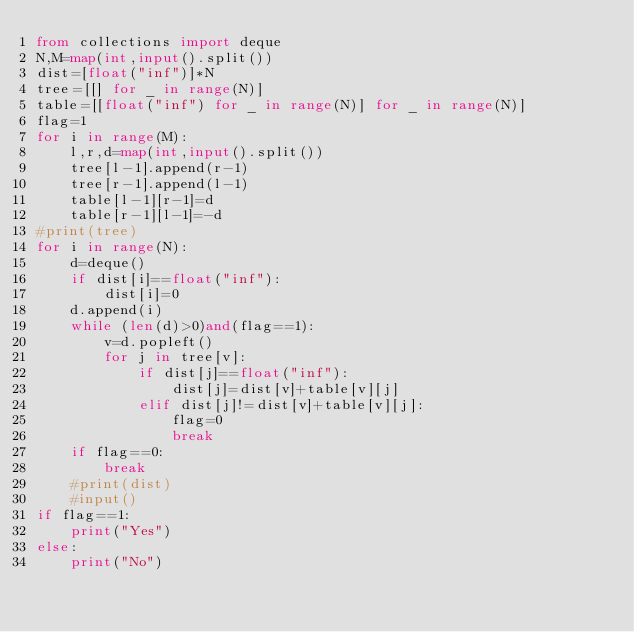Convert code to text. <code><loc_0><loc_0><loc_500><loc_500><_Python_>from collections import deque
N,M=map(int,input().split())
dist=[float("inf")]*N
tree=[[] for _ in range(N)]
table=[[float("inf") for _ in range(N)] for _ in range(N)]
flag=1
for i in range(M):
    l,r,d=map(int,input().split())
    tree[l-1].append(r-1)
    tree[r-1].append(l-1)
    table[l-1][r-1]=d
    table[r-1][l-1]=-d
#print(tree)
for i in range(N):
    d=deque()
    if dist[i]==float("inf"):
        dist[i]=0
    d.append(i)
    while (len(d)>0)and(flag==1):
        v=d.popleft()
        for j in tree[v]:
            if dist[j]==float("inf"):
                dist[j]=dist[v]+table[v][j]
            elif dist[j]!=dist[v]+table[v][j]:
                flag=0
                break
    if flag==0:
        break
    #print(dist)
    #input()
if flag==1:
    print("Yes")
else:
    print("No")</code> 